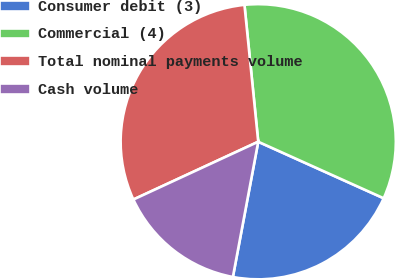Convert chart to OTSL. <chart><loc_0><loc_0><loc_500><loc_500><pie_chart><fcel>Consumer debit (3)<fcel>Commercial (4)<fcel>Total nominal payments volume<fcel>Cash volume<nl><fcel>21.21%<fcel>33.33%<fcel>30.3%<fcel>15.15%<nl></chart> 